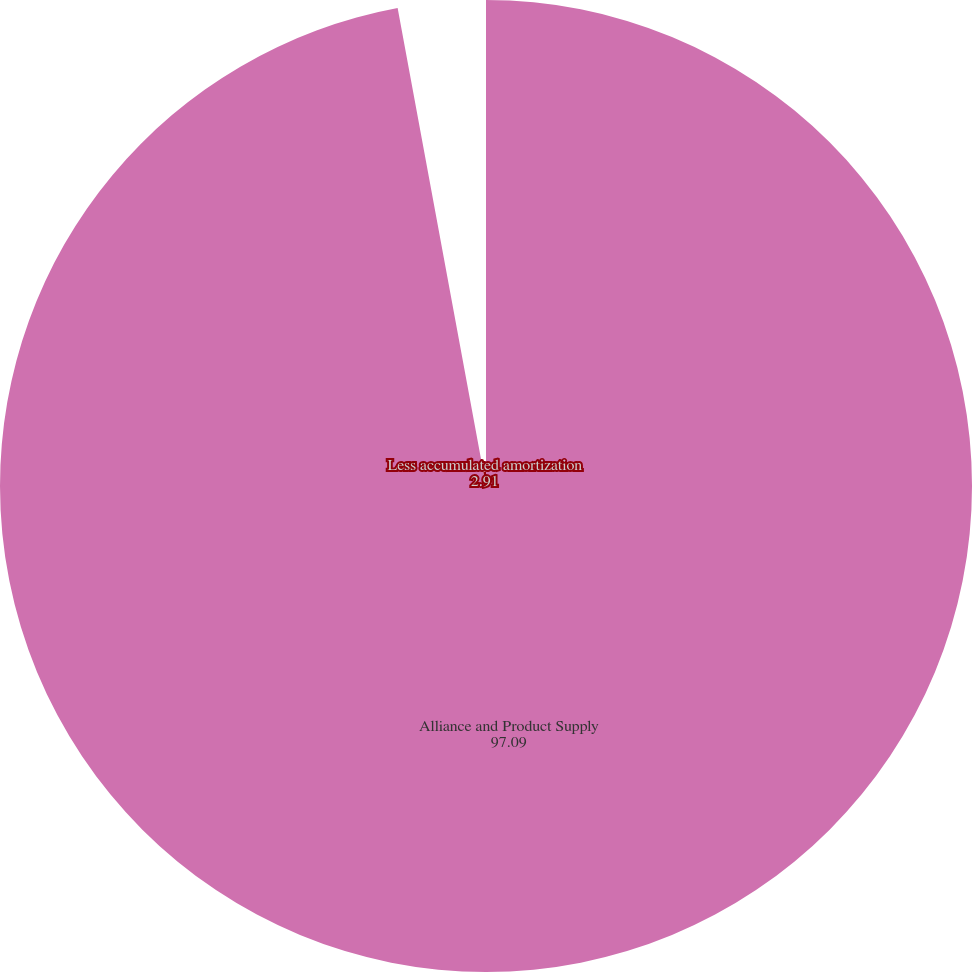Convert chart. <chart><loc_0><loc_0><loc_500><loc_500><pie_chart><fcel>Alliance and Product Supply<fcel>Less accumulated amortization<nl><fcel>97.09%<fcel>2.91%<nl></chart> 